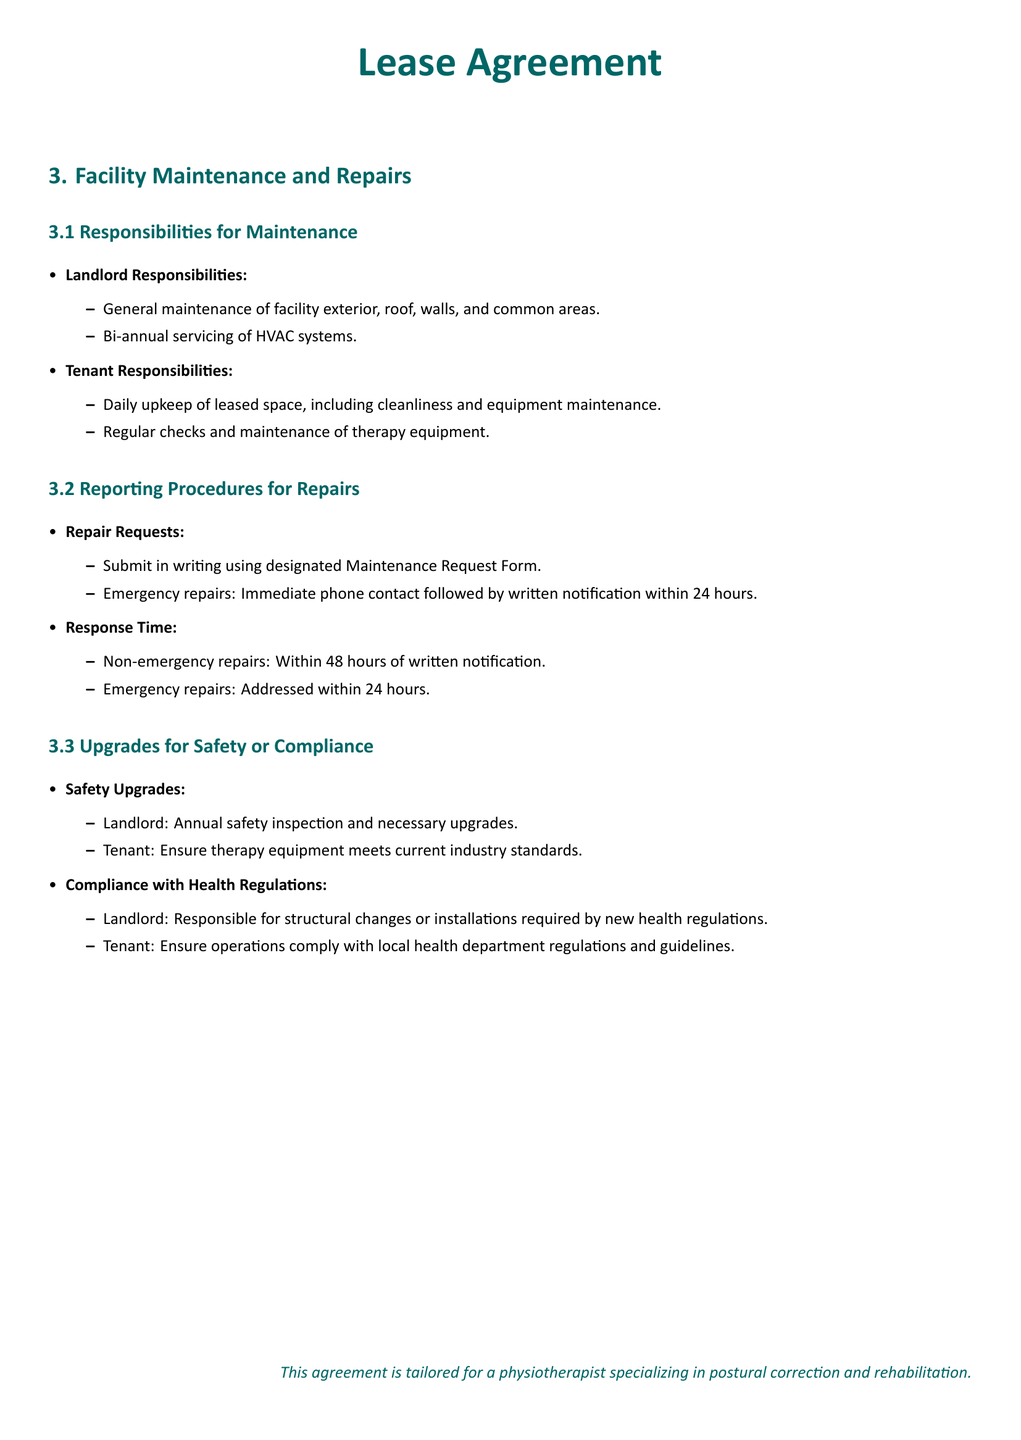What are the landlord's responsibilities for maintenance? The landlord is responsible for the general maintenance of the facility exterior, roof, walls, and common areas, as well as bi-annual servicing of HVAC systems.
Answer: General maintenance and HVAC servicing What must the tenant regularly check and maintain? The tenant is responsible for the regular checks and maintenance of therapy equipment in the leased space.
Answer: Therapy equipment What is the response time for non-emergency repairs? Non-emergency repairs must be addressed within 48 hours of written notification as per the document's provisions.
Answer: Within 48 hours What must be done for emergency repairs? Emergency repairs require immediate phone contact followed by written notification within 24 hours to ensure a prompt response.
Answer: Immediate phone contact and written notification Who is responsible for structural changes required by new health regulations? The landlord is responsible for making structural changes or installations required by any new health regulations.
Answer: Landlord What is the purpose of the Maintenance Request Form? The Maintenance Request Form is used by the tenant to submit repair requests in writing to ensure proper reporting procedures.
Answer: Repair requests submission How often does the landlord conduct safety inspections? The landlord is required to conduct an annual safety inspection to identify and implement necessary upgrades.
Answer: Annual What is the tenant's responsibility regarding health department regulations? The tenant must ensure operations comply with local health department regulations and guidelines throughout their lease term.
Answer: Ensure operations comply What type of upgrades is the landlord responsible for? The landlord is responsible for making necessary upgrades following the annual safety inspections to ensure ongoing safety compliance.
Answer: Safety upgrades What does the agreement state about the tenant's space upkeep? The tenant is responsible for the daily upkeep of the leased space, which includes cleanliness and the maintenance of their equipment.
Answer: Daily upkeep and cleanliness 